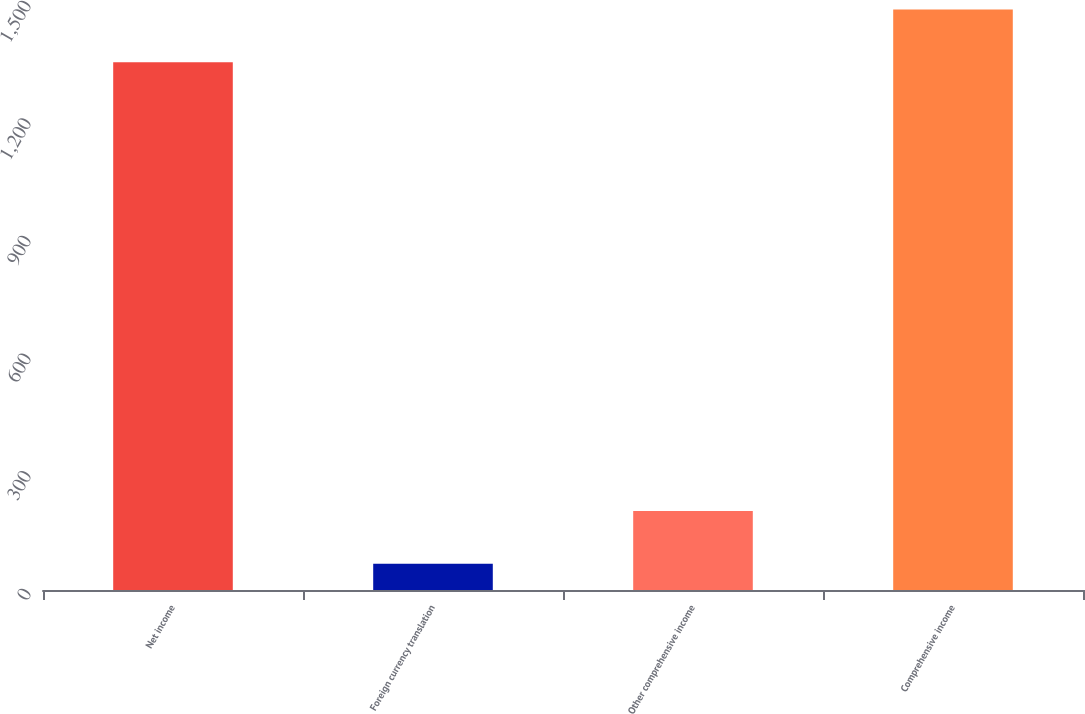Convert chart to OTSL. <chart><loc_0><loc_0><loc_500><loc_500><bar_chart><fcel>Net income<fcel>Foreign currency translation<fcel>Other comprehensive income<fcel>Comprehensive income<nl><fcel>1346<fcel>67<fcel>201.6<fcel>1480.6<nl></chart> 